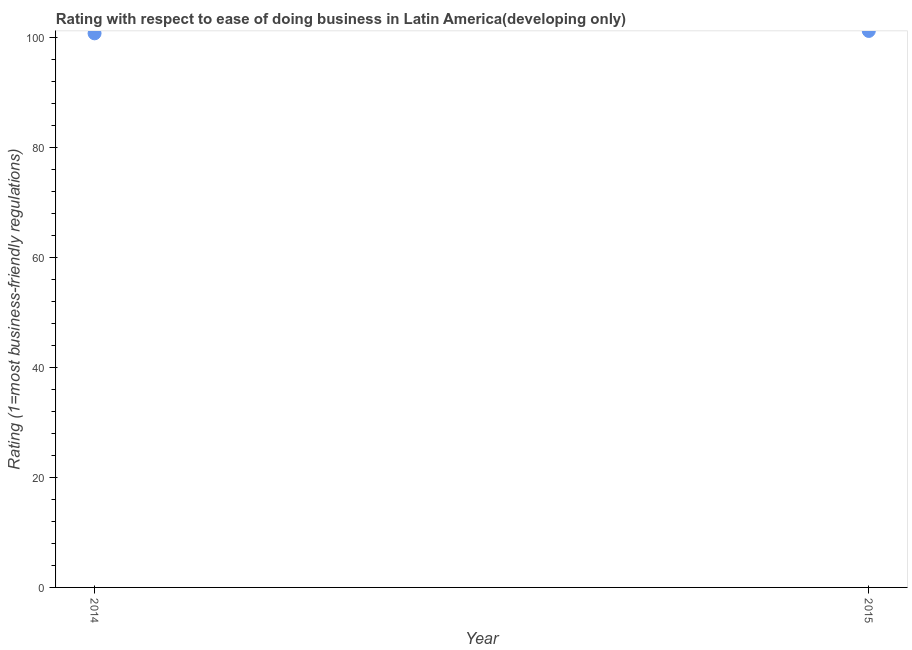What is the ease of doing business index in 2015?
Offer a terse response. 101.17. Across all years, what is the maximum ease of doing business index?
Provide a short and direct response. 101.17. Across all years, what is the minimum ease of doing business index?
Your answer should be compact. 100.74. In which year was the ease of doing business index maximum?
Offer a terse response. 2015. What is the sum of the ease of doing business index?
Offer a very short reply. 201.91. What is the difference between the ease of doing business index in 2014 and 2015?
Make the answer very short. -0.43. What is the average ease of doing business index per year?
Your answer should be compact. 100.96. What is the median ease of doing business index?
Your answer should be compact. 100.96. Do a majority of the years between 2015 and 2014 (inclusive) have ease of doing business index greater than 60 ?
Provide a succinct answer. No. What is the ratio of the ease of doing business index in 2014 to that in 2015?
Provide a succinct answer. 1. Does the graph contain any zero values?
Ensure brevity in your answer.  No. Does the graph contain grids?
Offer a very short reply. No. What is the title of the graph?
Your answer should be very brief. Rating with respect to ease of doing business in Latin America(developing only). What is the label or title of the Y-axis?
Offer a very short reply. Rating (1=most business-friendly regulations). What is the Rating (1=most business-friendly regulations) in 2014?
Offer a very short reply. 100.74. What is the Rating (1=most business-friendly regulations) in 2015?
Your response must be concise. 101.17. What is the difference between the Rating (1=most business-friendly regulations) in 2014 and 2015?
Your answer should be very brief. -0.43. What is the ratio of the Rating (1=most business-friendly regulations) in 2014 to that in 2015?
Keep it short and to the point. 1. 